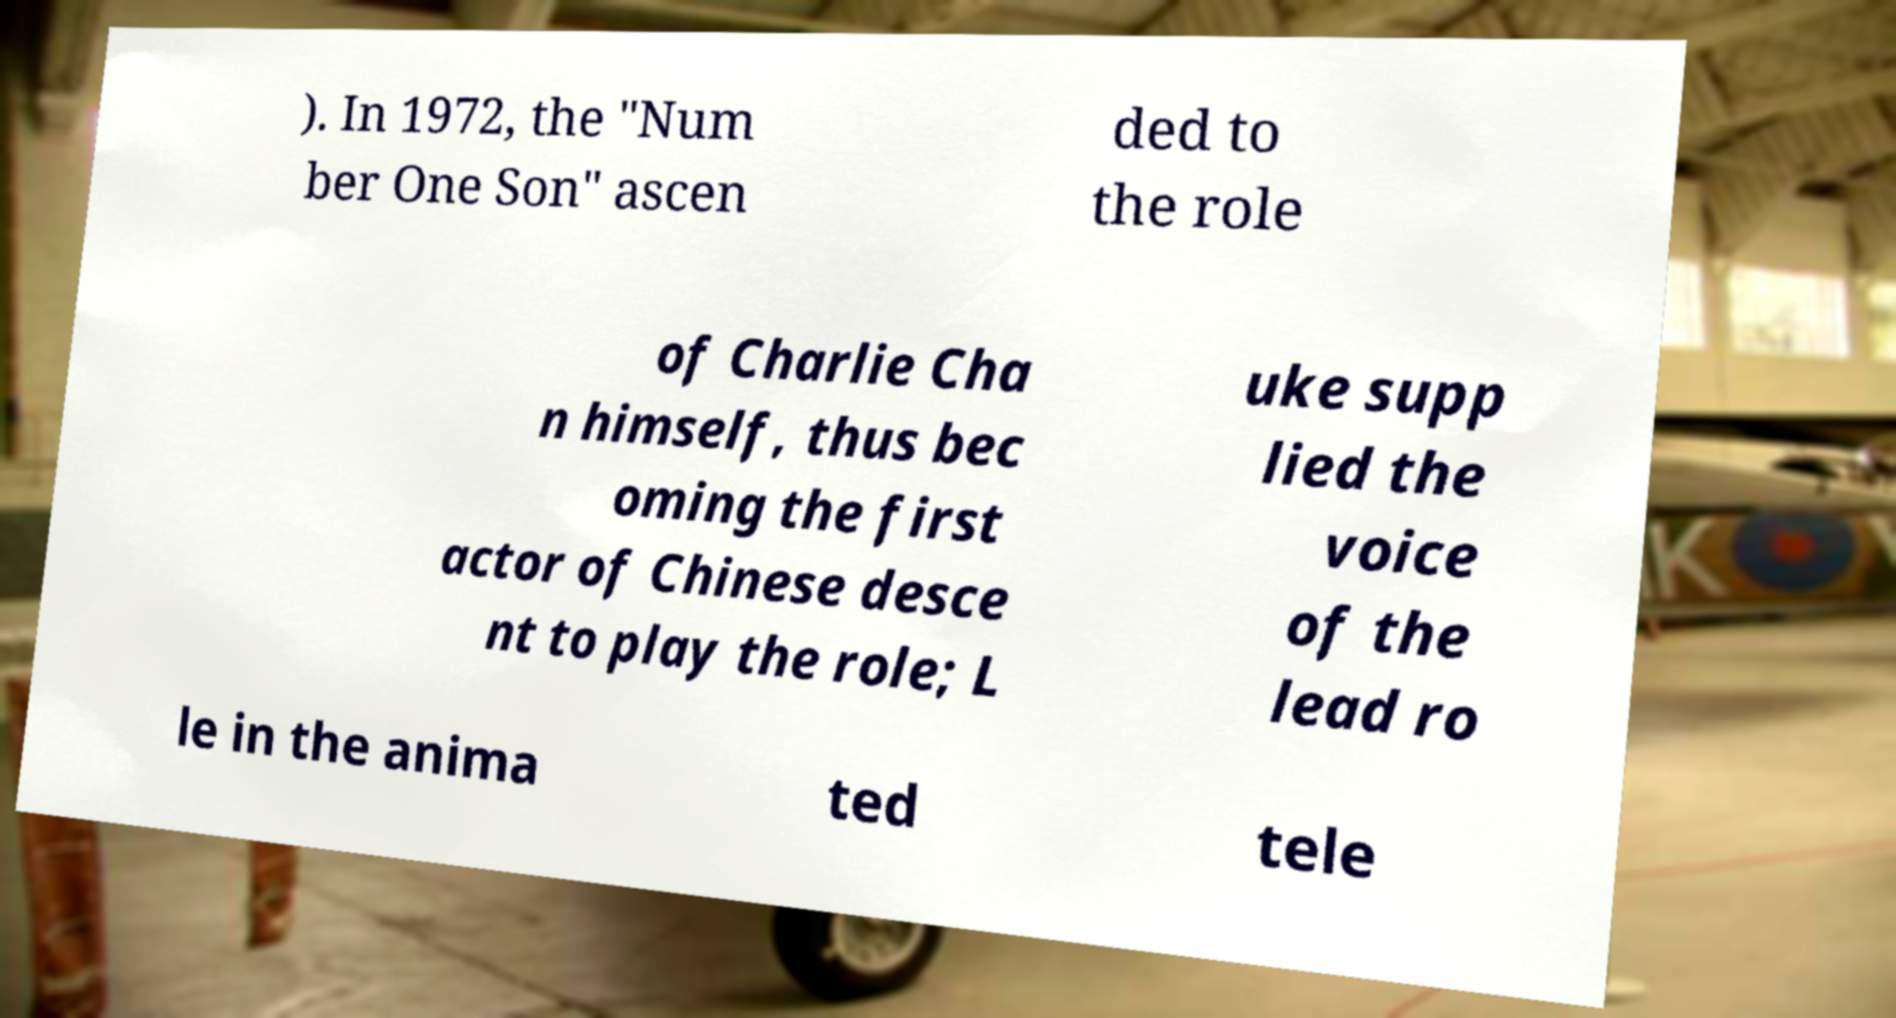Can you accurately transcribe the text from the provided image for me? ). In 1972, the "Num ber One Son" ascen ded to the role of Charlie Cha n himself, thus bec oming the first actor of Chinese desce nt to play the role; L uke supp lied the voice of the lead ro le in the anima ted tele 